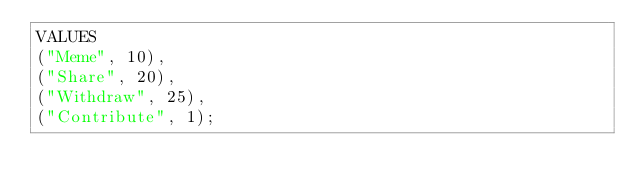Convert code to text. <code><loc_0><loc_0><loc_500><loc_500><_SQL_>VALUES
("Meme", 10),
("Share", 20),
("Withdraw", 25),
("Contribute", 1);
</code> 